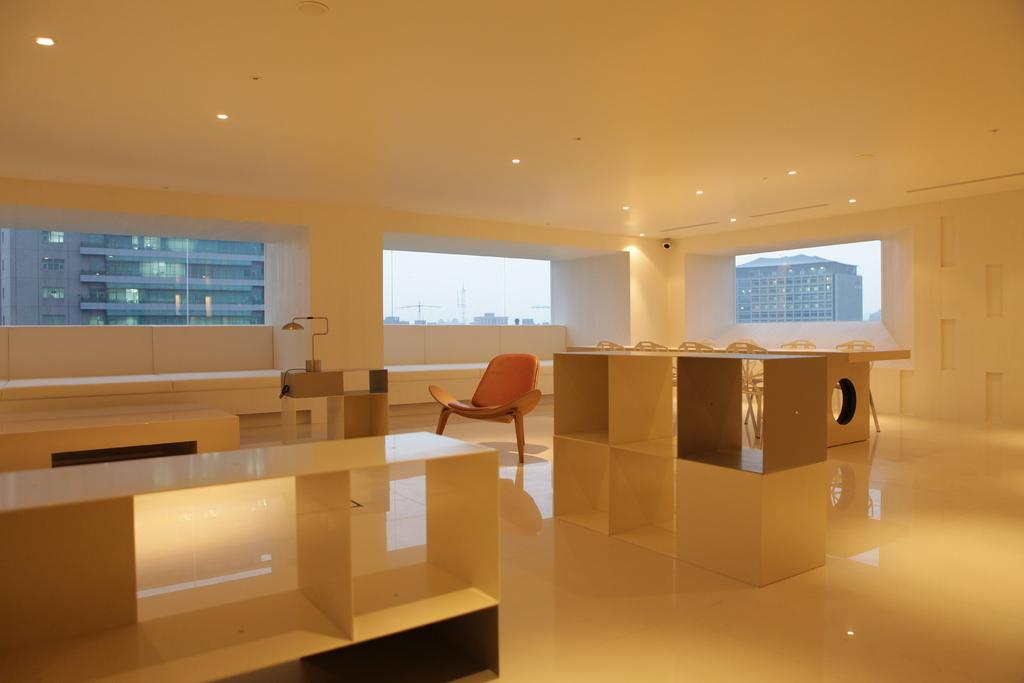What type of location is depicted in the image? The image shows the inside of a building. What type of furniture can be seen in the image? There are chairs and tables in the image. What part of the building is visible in the image? The floor is visible in the image. What can be seen through the windows in the image? Buildings, poles, and the sky are visible through the windows. What is located at the top of the image? There are lights at the top of the image. What type of lace is draped over the chairs in the image? There is no lace present in the image; only chairs, tables, and lights are visible. How many men are visible in the image? There are no men visible in the image; it shows the inside of a building with chairs, tables, and lights. 